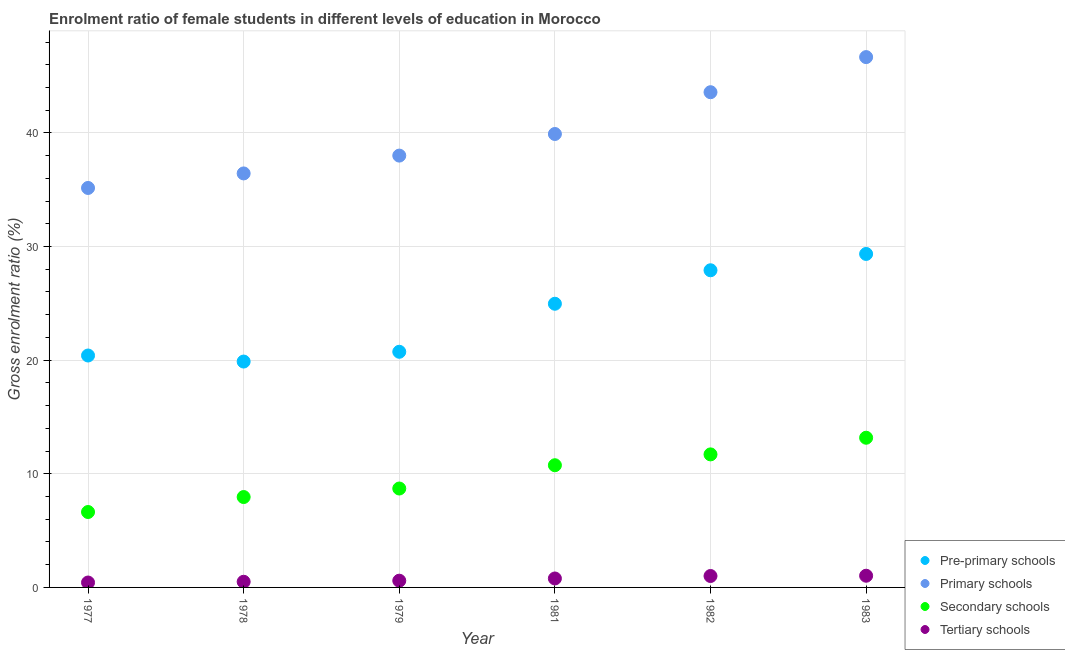What is the gross enrolment ratio(male) in pre-primary schools in 1978?
Ensure brevity in your answer.  19.88. Across all years, what is the maximum gross enrolment ratio(male) in primary schools?
Your answer should be compact. 46.67. Across all years, what is the minimum gross enrolment ratio(male) in primary schools?
Give a very brief answer. 35.16. In which year was the gross enrolment ratio(male) in primary schools maximum?
Give a very brief answer. 1983. In which year was the gross enrolment ratio(male) in pre-primary schools minimum?
Keep it short and to the point. 1978. What is the total gross enrolment ratio(male) in pre-primary schools in the graph?
Offer a terse response. 143.25. What is the difference between the gross enrolment ratio(male) in pre-primary schools in 1977 and that in 1983?
Your response must be concise. -8.94. What is the difference between the gross enrolment ratio(male) in pre-primary schools in 1981 and the gross enrolment ratio(male) in tertiary schools in 1983?
Keep it short and to the point. 23.94. What is the average gross enrolment ratio(male) in pre-primary schools per year?
Give a very brief answer. 23.87. In the year 1977, what is the difference between the gross enrolment ratio(male) in primary schools and gross enrolment ratio(male) in tertiary schools?
Your response must be concise. 34.72. What is the ratio of the gross enrolment ratio(male) in pre-primary schools in 1978 to that in 1982?
Ensure brevity in your answer.  0.71. Is the gross enrolment ratio(male) in tertiary schools in 1979 less than that in 1982?
Offer a very short reply. Yes. Is the difference between the gross enrolment ratio(male) in secondary schools in 1978 and 1979 greater than the difference between the gross enrolment ratio(male) in pre-primary schools in 1978 and 1979?
Provide a short and direct response. Yes. What is the difference between the highest and the second highest gross enrolment ratio(male) in secondary schools?
Your response must be concise. 1.47. What is the difference between the highest and the lowest gross enrolment ratio(male) in primary schools?
Offer a very short reply. 11.52. In how many years, is the gross enrolment ratio(male) in pre-primary schools greater than the average gross enrolment ratio(male) in pre-primary schools taken over all years?
Provide a succinct answer. 3. Is it the case that in every year, the sum of the gross enrolment ratio(male) in tertiary schools and gross enrolment ratio(male) in secondary schools is greater than the sum of gross enrolment ratio(male) in pre-primary schools and gross enrolment ratio(male) in primary schools?
Keep it short and to the point. No. Is it the case that in every year, the sum of the gross enrolment ratio(male) in pre-primary schools and gross enrolment ratio(male) in primary schools is greater than the gross enrolment ratio(male) in secondary schools?
Provide a succinct answer. Yes. Is the gross enrolment ratio(male) in secondary schools strictly greater than the gross enrolment ratio(male) in tertiary schools over the years?
Offer a very short reply. Yes. How many dotlines are there?
Offer a very short reply. 4. How many years are there in the graph?
Your answer should be compact. 6. What is the difference between two consecutive major ticks on the Y-axis?
Your answer should be compact. 10. Are the values on the major ticks of Y-axis written in scientific E-notation?
Offer a very short reply. No. Does the graph contain any zero values?
Keep it short and to the point. No. Does the graph contain grids?
Provide a short and direct response. Yes. Where does the legend appear in the graph?
Offer a very short reply. Bottom right. How many legend labels are there?
Ensure brevity in your answer.  4. How are the legend labels stacked?
Offer a very short reply. Vertical. What is the title of the graph?
Give a very brief answer. Enrolment ratio of female students in different levels of education in Morocco. What is the label or title of the X-axis?
Provide a succinct answer. Year. What is the label or title of the Y-axis?
Provide a succinct answer. Gross enrolment ratio (%). What is the Gross enrolment ratio (%) in Pre-primary schools in 1977?
Give a very brief answer. 20.41. What is the Gross enrolment ratio (%) in Primary schools in 1977?
Your answer should be very brief. 35.16. What is the Gross enrolment ratio (%) of Secondary schools in 1977?
Give a very brief answer. 6.64. What is the Gross enrolment ratio (%) in Tertiary schools in 1977?
Keep it short and to the point. 0.43. What is the Gross enrolment ratio (%) of Pre-primary schools in 1978?
Your answer should be compact. 19.88. What is the Gross enrolment ratio (%) in Primary schools in 1978?
Your answer should be compact. 36.43. What is the Gross enrolment ratio (%) in Secondary schools in 1978?
Keep it short and to the point. 7.95. What is the Gross enrolment ratio (%) of Tertiary schools in 1978?
Keep it short and to the point. 0.5. What is the Gross enrolment ratio (%) of Pre-primary schools in 1979?
Ensure brevity in your answer.  20.74. What is the Gross enrolment ratio (%) in Primary schools in 1979?
Offer a very short reply. 38. What is the Gross enrolment ratio (%) of Secondary schools in 1979?
Ensure brevity in your answer.  8.7. What is the Gross enrolment ratio (%) in Tertiary schools in 1979?
Your answer should be very brief. 0.59. What is the Gross enrolment ratio (%) in Pre-primary schools in 1981?
Provide a succinct answer. 24.96. What is the Gross enrolment ratio (%) of Primary schools in 1981?
Ensure brevity in your answer.  39.9. What is the Gross enrolment ratio (%) in Secondary schools in 1981?
Offer a terse response. 10.75. What is the Gross enrolment ratio (%) in Tertiary schools in 1981?
Offer a terse response. 0.79. What is the Gross enrolment ratio (%) in Pre-primary schools in 1982?
Give a very brief answer. 27.91. What is the Gross enrolment ratio (%) of Primary schools in 1982?
Keep it short and to the point. 43.58. What is the Gross enrolment ratio (%) in Secondary schools in 1982?
Keep it short and to the point. 11.71. What is the Gross enrolment ratio (%) in Tertiary schools in 1982?
Make the answer very short. 1.01. What is the Gross enrolment ratio (%) of Pre-primary schools in 1983?
Offer a terse response. 29.35. What is the Gross enrolment ratio (%) in Primary schools in 1983?
Offer a terse response. 46.67. What is the Gross enrolment ratio (%) in Secondary schools in 1983?
Provide a succinct answer. 13.17. What is the Gross enrolment ratio (%) in Tertiary schools in 1983?
Your answer should be compact. 1.03. Across all years, what is the maximum Gross enrolment ratio (%) of Pre-primary schools?
Offer a very short reply. 29.35. Across all years, what is the maximum Gross enrolment ratio (%) in Primary schools?
Your answer should be very brief. 46.67. Across all years, what is the maximum Gross enrolment ratio (%) in Secondary schools?
Ensure brevity in your answer.  13.17. Across all years, what is the maximum Gross enrolment ratio (%) in Tertiary schools?
Keep it short and to the point. 1.03. Across all years, what is the minimum Gross enrolment ratio (%) of Pre-primary schools?
Provide a short and direct response. 19.88. Across all years, what is the minimum Gross enrolment ratio (%) in Primary schools?
Make the answer very short. 35.16. Across all years, what is the minimum Gross enrolment ratio (%) in Secondary schools?
Your response must be concise. 6.64. Across all years, what is the minimum Gross enrolment ratio (%) of Tertiary schools?
Provide a short and direct response. 0.43. What is the total Gross enrolment ratio (%) in Pre-primary schools in the graph?
Provide a short and direct response. 143.25. What is the total Gross enrolment ratio (%) in Primary schools in the graph?
Ensure brevity in your answer.  239.75. What is the total Gross enrolment ratio (%) of Secondary schools in the graph?
Make the answer very short. 58.93. What is the total Gross enrolment ratio (%) in Tertiary schools in the graph?
Your answer should be very brief. 4.35. What is the difference between the Gross enrolment ratio (%) of Pre-primary schools in 1977 and that in 1978?
Ensure brevity in your answer.  0.53. What is the difference between the Gross enrolment ratio (%) of Primary schools in 1977 and that in 1978?
Your answer should be very brief. -1.28. What is the difference between the Gross enrolment ratio (%) in Secondary schools in 1977 and that in 1978?
Provide a short and direct response. -1.32. What is the difference between the Gross enrolment ratio (%) in Tertiary schools in 1977 and that in 1978?
Provide a short and direct response. -0.07. What is the difference between the Gross enrolment ratio (%) in Pre-primary schools in 1977 and that in 1979?
Offer a terse response. -0.33. What is the difference between the Gross enrolment ratio (%) of Primary schools in 1977 and that in 1979?
Your response must be concise. -2.85. What is the difference between the Gross enrolment ratio (%) in Secondary schools in 1977 and that in 1979?
Provide a short and direct response. -2.07. What is the difference between the Gross enrolment ratio (%) in Tertiary schools in 1977 and that in 1979?
Make the answer very short. -0.16. What is the difference between the Gross enrolment ratio (%) in Pre-primary schools in 1977 and that in 1981?
Your response must be concise. -4.55. What is the difference between the Gross enrolment ratio (%) of Primary schools in 1977 and that in 1981?
Your response must be concise. -4.75. What is the difference between the Gross enrolment ratio (%) in Secondary schools in 1977 and that in 1981?
Offer a terse response. -4.12. What is the difference between the Gross enrolment ratio (%) in Tertiary schools in 1977 and that in 1981?
Make the answer very short. -0.36. What is the difference between the Gross enrolment ratio (%) in Pre-primary schools in 1977 and that in 1982?
Offer a very short reply. -7.5. What is the difference between the Gross enrolment ratio (%) in Primary schools in 1977 and that in 1982?
Your response must be concise. -8.43. What is the difference between the Gross enrolment ratio (%) in Secondary schools in 1977 and that in 1982?
Make the answer very short. -5.07. What is the difference between the Gross enrolment ratio (%) of Tertiary schools in 1977 and that in 1982?
Your answer should be compact. -0.57. What is the difference between the Gross enrolment ratio (%) of Pre-primary schools in 1977 and that in 1983?
Your answer should be very brief. -8.94. What is the difference between the Gross enrolment ratio (%) of Primary schools in 1977 and that in 1983?
Offer a very short reply. -11.52. What is the difference between the Gross enrolment ratio (%) of Secondary schools in 1977 and that in 1983?
Give a very brief answer. -6.54. What is the difference between the Gross enrolment ratio (%) in Tertiary schools in 1977 and that in 1983?
Provide a succinct answer. -0.6. What is the difference between the Gross enrolment ratio (%) in Pre-primary schools in 1978 and that in 1979?
Offer a terse response. -0.86. What is the difference between the Gross enrolment ratio (%) of Primary schools in 1978 and that in 1979?
Give a very brief answer. -1.57. What is the difference between the Gross enrolment ratio (%) of Secondary schools in 1978 and that in 1979?
Make the answer very short. -0.75. What is the difference between the Gross enrolment ratio (%) of Tertiary schools in 1978 and that in 1979?
Keep it short and to the point. -0.09. What is the difference between the Gross enrolment ratio (%) in Pre-primary schools in 1978 and that in 1981?
Your answer should be very brief. -5.09. What is the difference between the Gross enrolment ratio (%) of Primary schools in 1978 and that in 1981?
Provide a succinct answer. -3.47. What is the difference between the Gross enrolment ratio (%) in Secondary schools in 1978 and that in 1981?
Make the answer very short. -2.8. What is the difference between the Gross enrolment ratio (%) in Tertiary schools in 1978 and that in 1981?
Give a very brief answer. -0.29. What is the difference between the Gross enrolment ratio (%) of Pre-primary schools in 1978 and that in 1982?
Offer a very short reply. -8.03. What is the difference between the Gross enrolment ratio (%) in Primary schools in 1978 and that in 1982?
Provide a succinct answer. -7.15. What is the difference between the Gross enrolment ratio (%) of Secondary schools in 1978 and that in 1982?
Provide a short and direct response. -3.75. What is the difference between the Gross enrolment ratio (%) in Tertiary schools in 1978 and that in 1982?
Your response must be concise. -0.51. What is the difference between the Gross enrolment ratio (%) of Pre-primary schools in 1978 and that in 1983?
Your response must be concise. -9.47. What is the difference between the Gross enrolment ratio (%) in Primary schools in 1978 and that in 1983?
Give a very brief answer. -10.24. What is the difference between the Gross enrolment ratio (%) of Secondary schools in 1978 and that in 1983?
Your answer should be compact. -5.22. What is the difference between the Gross enrolment ratio (%) in Tertiary schools in 1978 and that in 1983?
Provide a short and direct response. -0.53. What is the difference between the Gross enrolment ratio (%) in Pre-primary schools in 1979 and that in 1981?
Offer a very short reply. -4.23. What is the difference between the Gross enrolment ratio (%) in Primary schools in 1979 and that in 1981?
Give a very brief answer. -1.9. What is the difference between the Gross enrolment ratio (%) of Secondary schools in 1979 and that in 1981?
Offer a terse response. -2.05. What is the difference between the Gross enrolment ratio (%) of Tertiary schools in 1979 and that in 1981?
Keep it short and to the point. -0.2. What is the difference between the Gross enrolment ratio (%) in Pre-primary schools in 1979 and that in 1982?
Ensure brevity in your answer.  -7.17. What is the difference between the Gross enrolment ratio (%) of Primary schools in 1979 and that in 1982?
Provide a succinct answer. -5.58. What is the difference between the Gross enrolment ratio (%) in Secondary schools in 1979 and that in 1982?
Provide a succinct answer. -3. What is the difference between the Gross enrolment ratio (%) of Tertiary schools in 1979 and that in 1982?
Your response must be concise. -0.41. What is the difference between the Gross enrolment ratio (%) in Pre-primary schools in 1979 and that in 1983?
Ensure brevity in your answer.  -8.61. What is the difference between the Gross enrolment ratio (%) of Primary schools in 1979 and that in 1983?
Provide a short and direct response. -8.67. What is the difference between the Gross enrolment ratio (%) of Secondary schools in 1979 and that in 1983?
Ensure brevity in your answer.  -4.47. What is the difference between the Gross enrolment ratio (%) in Tertiary schools in 1979 and that in 1983?
Your answer should be compact. -0.44. What is the difference between the Gross enrolment ratio (%) in Pre-primary schools in 1981 and that in 1982?
Ensure brevity in your answer.  -2.95. What is the difference between the Gross enrolment ratio (%) of Primary schools in 1981 and that in 1982?
Provide a short and direct response. -3.68. What is the difference between the Gross enrolment ratio (%) in Secondary schools in 1981 and that in 1982?
Ensure brevity in your answer.  -0.95. What is the difference between the Gross enrolment ratio (%) of Tertiary schools in 1981 and that in 1982?
Your response must be concise. -0.22. What is the difference between the Gross enrolment ratio (%) of Pre-primary schools in 1981 and that in 1983?
Provide a short and direct response. -4.38. What is the difference between the Gross enrolment ratio (%) in Primary schools in 1981 and that in 1983?
Ensure brevity in your answer.  -6.77. What is the difference between the Gross enrolment ratio (%) in Secondary schools in 1981 and that in 1983?
Offer a very short reply. -2.42. What is the difference between the Gross enrolment ratio (%) in Tertiary schools in 1981 and that in 1983?
Ensure brevity in your answer.  -0.24. What is the difference between the Gross enrolment ratio (%) in Pre-primary schools in 1982 and that in 1983?
Provide a succinct answer. -1.44. What is the difference between the Gross enrolment ratio (%) in Primary schools in 1982 and that in 1983?
Offer a terse response. -3.09. What is the difference between the Gross enrolment ratio (%) in Secondary schools in 1982 and that in 1983?
Ensure brevity in your answer.  -1.47. What is the difference between the Gross enrolment ratio (%) in Tertiary schools in 1982 and that in 1983?
Offer a very short reply. -0.02. What is the difference between the Gross enrolment ratio (%) in Pre-primary schools in 1977 and the Gross enrolment ratio (%) in Primary schools in 1978?
Provide a succinct answer. -16.02. What is the difference between the Gross enrolment ratio (%) of Pre-primary schools in 1977 and the Gross enrolment ratio (%) of Secondary schools in 1978?
Your answer should be compact. 12.46. What is the difference between the Gross enrolment ratio (%) in Pre-primary schools in 1977 and the Gross enrolment ratio (%) in Tertiary schools in 1978?
Offer a very short reply. 19.91. What is the difference between the Gross enrolment ratio (%) of Primary schools in 1977 and the Gross enrolment ratio (%) of Secondary schools in 1978?
Keep it short and to the point. 27.2. What is the difference between the Gross enrolment ratio (%) in Primary schools in 1977 and the Gross enrolment ratio (%) in Tertiary schools in 1978?
Provide a short and direct response. 34.66. What is the difference between the Gross enrolment ratio (%) of Secondary schools in 1977 and the Gross enrolment ratio (%) of Tertiary schools in 1978?
Ensure brevity in your answer.  6.14. What is the difference between the Gross enrolment ratio (%) in Pre-primary schools in 1977 and the Gross enrolment ratio (%) in Primary schools in 1979?
Your answer should be compact. -17.59. What is the difference between the Gross enrolment ratio (%) of Pre-primary schools in 1977 and the Gross enrolment ratio (%) of Secondary schools in 1979?
Keep it short and to the point. 11.71. What is the difference between the Gross enrolment ratio (%) in Pre-primary schools in 1977 and the Gross enrolment ratio (%) in Tertiary schools in 1979?
Give a very brief answer. 19.82. What is the difference between the Gross enrolment ratio (%) in Primary schools in 1977 and the Gross enrolment ratio (%) in Secondary schools in 1979?
Provide a succinct answer. 26.45. What is the difference between the Gross enrolment ratio (%) in Primary schools in 1977 and the Gross enrolment ratio (%) in Tertiary schools in 1979?
Ensure brevity in your answer.  34.56. What is the difference between the Gross enrolment ratio (%) in Secondary schools in 1977 and the Gross enrolment ratio (%) in Tertiary schools in 1979?
Your answer should be very brief. 6.04. What is the difference between the Gross enrolment ratio (%) in Pre-primary schools in 1977 and the Gross enrolment ratio (%) in Primary schools in 1981?
Your response must be concise. -19.49. What is the difference between the Gross enrolment ratio (%) of Pre-primary schools in 1977 and the Gross enrolment ratio (%) of Secondary schools in 1981?
Your response must be concise. 9.66. What is the difference between the Gross enrolment ratio (%) in Pre-primary schools in 1977 and the Gross enrolment ratio (%) in Tertiary schools in 1981?
Ensure brevity in your answer.  19.62. What is the difference between the Gross enrolment ratio (%) of Primary schools in 1977 and the Gross enrolment ratio (%) of Secondary schools in 1981?
Your response must be concise. 24.4. What is the difference between the Gross enrolment ratio (%) in Primary schools in 1977 and the Gross enrolment ratio (%) in Tertiary schools in 1981?
Keep it short and to the point. 34.37. What is the difference between the Gross enrolment ratio (%) of Secondary schools in 1977 and the Gross enrolment ratio (%) of Tertiary schools in 1981?
Provide a succinct answer. 5.85. What is the difference between the Gross enrolment ratio (%) in Pre-primary schools in 1977 and the Gross enrolment ratio (%) in Primary schools in 1982?
Your response must be concise. -23.17. What is the difference between the Gross enrolment ratio (%) in Pre-primary schools in 1977 and the Gross enrolment ratio (%) in Secondary schools in 1982?
Provide a short and direct response. 8.7. What is the difference between the Gross enrolment ratio (%) in Pre-primary schools in 1977 and the Gross enrolment ratio (%) in Tertiary schools in 1982?
Keep it short and to the point. 19.4. What is the difference between the Gross enrolment ratio (%) in Primary schools in 1977 and the Gross enrolment ratio (%) in Secondary schools in 1982?
Your answer should be compact. 23.45. What is the difference between the Gross enrolment ratio (%) of Primary schools in 1977 and the Gross enrolment ratio (%) of Tertiary schools in 1982?
Your answer should be compact. 34.15. What is the difference between the Gross enrolment ratio (%) of Secondary schools in 1977 and the Gross enrolment ratio (%) of Tertiary schools in 1982?
Keep it short and to the point. 5.63. What is the difference between the Gross enrolment ratio (%) in Pre-primary schools in 1977 and the Gross enrolment ratio (%) in Primary schools in 1983?
Ensure brevity in your answer.  -26.26. What is the difference between the Gross enrolment ratio (%) of Pre-primary schools in 1977 and the Gross enrolment ratio (%) of Secondary schools in 1983?
Make the answer very short. 7.24. What is the difference between the Gross enrolment ratio (%) of Pre-primary schools in 1977 and the Gross enrolment ratio (%) of Tertiary schools in 1983?
Make the answer very short. 19.38. What is the difference between the Gross enrolment ratio (%) in Primary schools in 1977 and the Gross enrolment ratio (%) in Secondary schools in 1983?
Keep it short and to the point. 21.98. What is the difference between the Gross enrolment ratio (%) of Primary schools in 1977 and the Gross enrolment ratio (%) of Tertiary schools in 1983?
Make the answer very short. 34.13. What is the difference between the Gross enrolment ratio (%) of Secondary schools in 1977 and the Gross enrolment ratio (%) of Tertiary schools in 1983?
Your answer should be very brief. 5.61. What is the difference between the Gross enrolment ratio (%) of Pre-primary schools in 1978 and the Gross enrolment ratio (%) of Primary schools in 1979?
Your answer should be compact. -18.12. What is the difference between the Gross enrolment ratio (%) in Pre-primary schools in 1978 and the Gross enrolment ratio (%) in Secondary schools in 1979?
Make the answer very short. 11.17. What is the difference between the Gross enrolment ratio (%) of Pre-primary schools in 1978 and the Gross enrolment ratio (%) of Tertiary schools in 1979?
Provide a short and direct response. 19.29. What is the difference between the Gross enrolment ratio (%) of Primary schools in 1978 and the Gross enrolment ratio (%) of Secondary schools in 1979?
Your answer should be very brief. 27.73. What is the difference between the Gross enrolment ratio (%) of Primary schools in 1978 and the Gross enrolment ratio (%) of Tertiary schools in 1979?
Your response must be concise. 35.84. What is the difference between the Gross enrolment ratio (%) in Secondary schools in 1978 and the Gross enrolment ratio (%) in Tertiary schools in 1979?
Your answer should be compact. 7.36. What is the difference between the Gross enrolment ratio (%) in Pre-primary schools in 1978 and the Gross enrolment ratio (%) in Primary schools in 1981?
Provide a short and direct response. -20.03. What is the difference between the Gross enrolment ratio (%) of Pre-primary schools in 1978 and the Gross enrolment ratio (%) of Secondary schools in 1981?
Your answer should be very brief. 9.13. What is the difference between the Gross enrolment ratio (%) of Pre-primary schools in 1978 and the Gross enrolment ratio (%) of Tertiary schools in 1981?
Your answer should be very brief. 19.09. What is the difference between the Gross enrolment ratio (%) in Primary schools in 1978 and the Gross enrolment ratio (%) in Secondary schools in 1981?
Your answer should be compact. 25.68. What is the difference between the Gross enrolment ratio (%) of Primary schools in 1978 and the Gross enrolment ratio (%) of Tertiary schools in 1981?
Give a very brief answer. 35.65. What is the difference between the Gross enrolment ratio (%) of Secondary schools in 1978 and the Gross enrolment ratio (%) of Tertiary schools in 1981?
Ensure brevity in your answer.  7.17. What is the difference between the Gross enrolment ratio (%) in Pre-primary schools in 1978 and the Gross enrolment ratio (%) in Primary schools in 1982?
Offer a terse response. -23.7. What is the difference between the Gross enrolment ratio (%) of Pre-primary schools in 1978 and the Gross enrolment ratio (%) of Secondary schools in 1982?
Offer a terse response. 8.17. What is the difference between the Gross enrolment ratio (%) of Pre-primary schools in 1978 and the Gross enrolment ratio (%) of Tertiary schools in 1982?
Provide a short and direct response. 18.87. What is the difference between the Gross enrolment ratio (%) in Primary schools in 1978 and the Gross enrolment ratio (%) in Secondary schools in 1982?
Offer a very short reply. 24.73. What is the difference between the Gross enrolment ratio (%) of Primary schools in 1978 and the Gross enrolment ratio (%) of Tertiary schools in 1982?
Give a very brief answer. 35.43. What is the difference between the Gross enrolment ratio (%) in Secondary schools in 1978 and the Gross enrolment ratio (%) in Tertiary schools in 1982?
Your answer should be compact. 6.95. What is the difference between the Gross enrolment ratio (%) of Pre-primary schools in 1978 and the Gross enrolment ratio (%) of Primary schools in 1983?
Give a very brief answer. -26.79. What is the difference between the Gross enrolment ratio (%) in Pre-primary schools in 1978 and the Gross enrolment ratio (%) in Secondary schools in 1983?
Ensure brevity in your answer.  6.71. What is the difference between the Gross enrolment ratio (%) in Pre-primary schools in 1978 and the Gross enrolment ratio (%) in Tertiary schools in 1983?
Your answer should be compact. 18.85. What is the difference between the Gross enrolment ratio (%) of Primary schools in 1978 and the Gross enrolment ratio (%) of Secondary schools in 1983?
Keep it short and to the point. 23.26. What is the difference between the Gross enrolment ratio (%) of Primary schools in 1978 and the Gross enrolment ratio (%) of Tertiary schools in 1983?
Provide a short and direct response. 35.41. What is the difference between the Gross enrolment ratio (%) in Secondary schools in 1978 and the Gross enrolment ratio (%) in Tertiary schools in 1983?
Offer a terse response. 6.93. What is the difference between the Gross enrolment ratio (%) of Pre-primary schools in 1979 and the Gross enrolment ratio (%) of Primary schools in 1981?
Your answer should be compact. -19.17. What is the difference between the Gross enrolment ratio (%) in Pre-primary schools in 1979 and the Gross enrolment ratio (%) in Secondary schools in 1981?
Your answer should be compact. 9.98. What is the difference between the Gross enrolment ratio (%) in Pre-primary schools in 1979 and the Gross enrolment ratio (%) in Tertiary schools in 1981?
Provide a succinct answer. 19.95. What is the difference between the Gross enrolment ratio (%) in Primary schools in 1979 and the Gross enrolment ratio (%) in Secondary schools in 1981?
Make the answer very short. 27.25. What is the difference between the Gross enrolment ratio (%) in Primary schools in 1979 and the Gross enrolment ratio (%) in Tertiary schools in 1981?
Your answer should be compact. 37.21. What is the difference between the Gross enrolment ratio (%) of Secondary schools in 1979 and the Gross enrolment ratio (%) of Tertiary schools in 1981?
Offer a terse response. 7.92. What is the difference between the Gross enrolment ratio (%) in Pre-primary schools in 1979 and the Gross enrolment ratio (%) in Primary schools in 1982?
Keep it short and to the point. -22.84. What is the difference between the Gross enrolment ratio (%) of Pre-primary schools in 1979 and the Gross enrolment ratio (%) of Secondary schools in 1982?
Offer a very short reply. 9.03. What is the difference between the Gross enrolment ratio (%) in Pre-primary schools in 1979 and the Gross enrolment ratio (%) in Tertiary schools in 1982?
Give a very brief answer. 19.73. What is the difference between the Gross enrolment ratio (%) of Primary schools in 1979 and the Gross enrolment ratio (%) of Secondary schools in 1982?
Provide a succinct answer. 26.29. What is the difference between the Gross enrolment ratio (%) of Primary schools in 1979 and the Gross enrolment ratio (%) of Tertiary schools in 1982?
Give a very brief answer. 37. What is the difference between the Gross enrolment ratio (%) of Secondary schools in 1979 and the Gross enrolment ratio (%) of Tertiary schools in 1982?
Your response must be concise. 7.7. What is the difference between the Gross enrolment ratio (%) of Pre-primary schools in 1979 and the Gross enrolment ratio (%) of Primary schools in 1983?
Ensure brevity in your answer.  -25.93. What is the difference between the Gross enrolment ratio (%) of Pre-primary schools in 1979 and the Gross enrolment ratio (%) of Secondary schools in 1983?
Your answer should be compact. 7.56. What is the difference between the Gross enrolment ratio (%) of Pre-primary schools in 1979 and the Gross enrolment ratio (%) of Tertiary schools in 1983?
Provide a short and direct response. 19.71. What is the difference between the Gross enrolment ratio (%) in Primary schools in 1979 and the Gross enrolment ratio (%) in Secondary schools in 1983?
Your response must be concise. 24.83. What is the difference between the Gross enrolment ratio (%) of Primary schools in 1979 and the Gross enrolment ratio (%) of Tertiary schools in 1983?
Your response must be concise. 36.97. What is the difference between the Gross enrolment ratio (%) in Secondary schools in 1979 and the Gross enrolment ratio (%) in Tertiary schools in 1983?
Make the answer very short. 7.68. What is the difference between the Gross enrolment ratio (%) in Pre-primary schools in 1981 and the Gross enrolment ratio (%) in Primary schools in 1982?
Provide a short and direct response. -18.62. What is the difference between the Gross enrolment ratio (%) in Pre-primary schools in 1981 and the Gross enrolment ratio (%) in Secondary schools in 1982?
Your answer should be very brief. 13.26. What is the difference between the Gross enrolment ratio (%) of Pre-primary schools in 1981 and the Gross enrolment ratio (%) of Tertiary schools in 1982?
Provide a succinct answer. 23.96. What is the difference between the Gross enrolment ratio (%) of Primary schools in 1981 and the Gross enrolment ratio (%) of Secondary schools in 1982?
Your answer should be very brief. 28.2. What is the difference between the Gross enrolment ratio (%) in Primary schools in 1981 and the Gross enrolment ratio (%) in Tertiary schools in 1982?
Ensure brevity in your answer.  38.9. What is the difference between the Gross enrolment ratio (%) of Secondary schools in 1981 and the Gross enrolment ratio (%) of Tertiary schools in 1982?
Offer a terse response. 9.75. What is the difference between the Gross enrolment ratio (%) in Pre-primary schools in 1981 and the Gross enrolment ratio (%) in Primary schools in 1983?
Your response must be concise. -21.71. What is the difference between the Gross enrolment ratio (%) of Pre-primary schools in 1981 and the Gross enrolment ratio (%) of Secondary schools in 1983?
Your answer should be compact. 11.79. What is the difference between the Gross enrolment ratio (%) in Pre-primary schools in 1981 and the Gross enrolment ratio (%) in Tertiary schools in 1983?
Provide a short and direct response. 23.94. What is the difference between the Gross enrolment ratio (%) in Primary schools in 1981 and the Gross enrolment ratio (%) in Secondary schools in 1983?
Ensure brevity in your answer.  26.73. What is the difference between the Gross enrolment ratio (%) of Primary schools in 1981 and the Gross enrolment ratio (%) of Tertiary schools in 1983?
Give a very brief answer. 38.88. What is the difference between the Gross enrolment ratio (%) of Secondary schools in 1981 and the Gross enrolment ratio (%) of Tertiary schools in 1983?
Ensure brevity in your answer.  9.72. What is the difference between the Gross enrolment ratio (%) in Pre-primary schools in 1982 and the Gross enrolment ratio (%) in Primary schools in 1983?
Provide a succinct answer. -18.76. What is the difference between the Gross enrolment ratio (%) in Pre-primary schools in 1982 and the Gross enrolment ratio (%) in Secondary schools in 1983?
Give a very brief answer. 14.74. What is the difference between the Gross enrolment ratio (%) of Pre-primary schools in 1982 and the Gross enrolment ratio (%) of Tertiary schools in 1983?
Offer a very short reply. 26.88. What is the difference between the Gross enrolment ratio (%) of Primary schools in 1982 and the Gross enrolment ratio (%) of Secondary schools in 1983?
Provide a succinct answer. 30.41. What is the difference between the Gross enrolment ratio (%) in Primary schools in 1982 and the Gross enrolment ratio (%) in Tertiary schools in 1983?
Make the answer very short. 42.55. What is the difference between the Gross enrolment ratio (%) of Secondary schools in 1982 and the Gross enrolment ratio (%) of Tertiary schools in 1983?
Make the answer very short. 10.68. What is the average Gross enrolment ratio (%) in Pre-primary schools per year?
Provide a short and direct response. 23.88. What is the average Gross enrolment ratio (%) of Primary schools per year?
Provide a short and direct response. 39.96. What is the average Gross enrolment ratio (%) in Secondary schools per year?
Your response must be concise. 9.82. What is the average Gross enrolment ratio (%) of Tertiary schools per year?
Keep it short and to the point. 0.72. In the year 1977, what is the difference between the Gross enrolment ratio (%) of Pre-primary schools and Gross enrolment ratio (%) of Primary schools?
Offer a terse response. -14.75. In the year 1977, what is the difference between the Gross enrolment ratio (%) of Pre-primary schools and Gross enrolment ratio (%) of Secondary schools?
Your answer should be very brief. 13.77. In the year 1977, what is the difference between the Gross enrolment ratio (%) of Pre-primary schools and Gross enrolment ratio (%) of Tertiary schools?
Provide a succinct answer. 19.98. In the year 1977, what is the difference between the Gross enrolment ratio (%) of Primary schools and Gross enrolment ratio (%) of Secondary schools?
Ensure brevity in your answer.  28.52. In the year 1977, what is the difference between the Gross enrolment ratio (%) of Primary schools and Gross enrolment ratio (%) of Tertiary schools?
Give a very brief answer. 34.72. In the year 1977, what is the difference between the Gross enrolment ratio (%) of Secondary schools and Gross enrolment ratio (%) of Tertiary schools?
Keep it short and to the point. 6.2. In the year 1978, what is the difference between the Gross enrolment ratio (%) in Pre-primary schools and Gross enrolment ratio (%) in Primary schools?
Provide a succinct answer. -16.56. In the year 1978, what is the difference between the Gross enrolment ratio (%) in Pre-primary schools and Gross enrolment ratio (%) in Secondary schools?
Offer a terse response. 11.92. In the year 1978, what is the difference between the Gross enrolment ratio (%) of Pre-primary schools and Gross enrolment ratio (%) of Tertiary schools?
Ensure brevity in your answer.  19.38. In the year 1978, what is the difference between the Gross enrolment ratio (%) in Primary schools and Gross enrolment ratio (%) in Secondary schools?
Ensure brevity in your answer.  28.48. In the year 1978, what is the difference between the Gross enrolment ratio (%) of Primary schools and Gross enrolment ratio (%) of Tertiary schools?
Make the answer very short. 35.94. In the year 1978, what is the difference between the Gross enrolment ratio (%) in Secondary schools and Gross enrolment ratio (%) in Tertiary schools?
Provide a short and direct response. 7.46. In the year 1979, what is the difference between the Gross enrolment ratio (%) in Pre-primary schools and Gross enrolment ratio (%) in Primary schools?
Offer a terse response. -17.26. In the year 1979, what is the difference between the Gross enrolment ratio (%) in Pre-primary schools and Gross enrolment ratio (%) in Secondary schools?
Offer a terse response. 12.03. In the year 1979, what is the difference between the Gross enrolment ratio (%) in Pre-primary schools and Gross enrolment ratio (%) in Tertiary schools?
Your response must be concise. 20.15. In the year 1979, what is the difference between the Gross enrolment ratio (%) of Primary schools and Gross enrolment ratio (%) of Secondary schools?
Provide a short and direct response. 29.3. In the year 1979, what is the difference between the Gross enrolment ratio (%) of Primary schools and Gross enrolment ratio (%) of Tertiary schools?
Offer a terse response. 37.41. In the year 1979, what is the difference between the Gross enrolment ratio (%) in Secondary schools and Gross enrolment ratio (%) in Tertiary schools?
Give a very brief answer. 8.11. In the year 1981, what is the difference between the Gross enrolment ratio (%) of Pre-primary schools and Gross enrolment ratio (%) of Primary schools?
Offer a very short reply. -14.94. In the year 1981, what is the difference between the Gross enrolment ratio (%) of Pre-primary schools and Gross enrolment ratio (%) of Secondary schools?
Keep it short and to the point. 14.21. In the year 1981, what is the difference between the Gross enrolment ratio (%) of Pre-primary schools and Gross enrolment ratio (%) of Tertiary schools?
Your response must be concise. 24.18. In the year 1981, what is the difference between the Gross enrolment ratio (%) of Primary schools and Gross enrolment ratio (%) of Secondary schools?
Offer a terse response. 29.15. In the year 1981, what is the difference between the Gross enrolment ratio (%) in Primary schools and Gross enrolment ratio (%) in Tertiary schools?
Ensure brevity in your answer.  39.12. In the year 1981, what is the difference between the Gross enrolment ratio (%) of Secondary schools and Gross enrolment ratio (%) of Tertiary schools?
Ensure brevity in your answer.  9.97. In the year 1982, what is the difference between the Gross enrolment ratio (%) in Pre-primary schools and Gross enrolment ratio (%) in Primary schools?
Make the answer very short. -15.67. In the year 1982, what is the difference between the Gross enrolment ratio (%) in Pre-primary schools and Gross enrolment ratio (%) in Secondary schools?
Offer a terse response. 16.2. In the year 1982, what is the difference between the Gross enrolment ratio (%) of Pre-primary schools and Gross enrolment ratio (%) of Tertiary schools?
Ensure brevity in your answer.  26.91. In the year 1982, what is the difference between the Gross enrolment ratio (%) of Primary schools and Gross enrolment ratio (%) of Secondary schools?
Your answer should be compact. 31.87. In the year 1982, what is the difference between the Gross enrolment ratio (%) in Primary schools and Gross enrolment ratio (%) in Tertiary schools?
Keep it short and to the point. 42.58. In the year 1982, what is the difference between the Gross enrolment ratio (%) of Secondary schools and Gross enrolment ratio (%) of Tertiary schools?
Offer a very short reply. 10.7. In the year 1983, what is the difference between the Gross enrolment ratio (%) in Pre-primary schools and Gross enrolment ratio (%) in Primary schools?
Make the answer very short. -17.32. In the year 1983, what is the difference between the Gross enrolment ratio (%) of Pre-primary schools and Gross enrolment ratio (%) of Secondary schools?
Ensure brevity in your answer.  16.17. In the year 1983, what is the difference between the Gross enrolment ratio (%) in Pre-primary schools and Gross enrolment ratio (%) in Tertiary schools?
Your answer should be compact. 28.32. In the year 1983, what is the difference between the Gross enrolment ratio (%) of Primary schools and Gross enrolment ratio (%) of Secondary schools?
Give a very brief answer. 33.5. In the year 1983, what is the difference between the Gross enrolment ratio (%) of Primary schools and Gross enrolment ratio (%) of Tertiary schools?
Your response must be concise. 45.64. In the year 1983, what is the difference between the Gross enrolment ratio (%) of Secondary schools and Gross enrolment ratio (%) of Tertiary schools?
Offer a very short reply. 12.14. What is the ratio of the Gross enrolment ratio (%) of Pre-primary schools in 1977 to that in 1978?
Provide a succinct answer. 1.03. What is the ratio of the Gross enrolment ratio (%) of Primary schools in 1977 to that in 1978?
Your answer should be very brief. 0.96. What is the ratio of the Gross enrolment ratio (%) of Secondary schools in 1977 to that in 1978?
Offer a terse response. 0.83. What is the ratio of the Gross enrolment ratio (%) in Tertiary schools in 1977 to that in 1978?
Offer a terse response. 0.87. What is the ratio of the Gross enrolment ratio (%) in Pre-primary schools in 1977 to that in 1979?
Keep it short and to the point. 0.98. What is the ratio of the Gross enrolment ratio (%) of Primary schools in 1977 to that in 1979?
Your response must be concise. 0.93. What is the ratio of the Gross enrolment ratio (%) in Secondary schools in 1977 to that in 1979?
Keep it short and to the point. 0.76. What is the ratio of the Gross enrolment ratio (%) of Tertiary schools in 1977 to that in 1979?
Provide a succinct answer. 0.73. What is the ratio of the Gross enrolment ratio (%) of Pre-primary schools in 1977 to that in 1981?
Keep it short and to the point. 0.82. What is the ratio of the Gross enrolment ratio (%) in Primary schools in 1977 to that in 1981?
Keep it short and to the point. 0.88. What is the ratio of the Gross enrolment ratio (%) in Secondary schools in 1977 to that in 1981?
Keep it short and to the point. 0.62. What is the ratio of the Gross enrolment ratio (%) of Tertiary schools in 1977 to that in 1981?
Offer a terse response. 0.55. What is the ratio of the Gross enrolment ratio (%) in Pre-primary schools in 1977 to that in 1982?
Your answer should be compact. 0.73. What is the ratio of the Gross enrolment ratio (%) in Primary schools in 1977 to that in 1982?
Your answer should be very brief. 0.81. What is the ratio of the Gross enrolment ratio (%) of Secondary schools in 1977 to that in 1982?
Your response must be concise. 0.57. What is the ratio of the Gross enrolment ratio (%) in Tertiary schools in 1977 to that in 1982?
Your response must be concise. 0.43. What is the ratio of the Gross enrolment ratio (%) of Pre-primary schools in 1977 to that in 1983?
Provide a succinct answer. 0.7. What is the ratio of the Gross enrolment ratio (%) of Primary schools in 1977 to that in 1983?
Make the answer very short. 0.75. What is the ratio of the Gross enrolment ratio (%) of Secondary schools in 1977 to that in 1983?
Your answer should be very brief. 0.5. What is the ratio of the Gross enrolment ratio (%) of Tertiary schools in 1977 to that in 1983?
Your answer should be compact. 0.42. What is the ratio of the Gross enrolment ratio (%) in Pre-primary schools in 1978 to that in 1979?
Ensure brevity in your answer.  0.96. What is the ratio of the Gross enrolment ratio (%) in Primary schools in 1978 to that in 1979?
Give a very brief answer. 0.96. What is the ratio of the Gross enrolment ratio (%) in Secondary schools in 1978 to that in 1979?
Keep it short and to the point. 0.91. What is the ratio of the Gross enrolment ratio (%) in Tertiary schools in 1978 to that in 1979?
Keep it short and to the point. 0.84. What is the ratio of the Gross enrolment ratio (%) in Pre-primary schools in 1978 to that in 1981?
Provide a short and direct response. 0.8. What is the ratio of the Gross enrolment ratio (%) of Primary schools in 1978 to that in 1981?
Your answer should be very brief. 0.91. What is the ratio of the Gross enrolment ratio (%) in Secondary schools in 1978 to that in 1981?
Your answer should be compact. 0.74. What is the ratio of the Gross enrolment ratio (%) of Tertiary schools in 1978 to that in 1981?
Offer a terse response. 0.63. What is the ratio of the Gross enrolment ratio (%) in Pre-primary schools in 1978 to that in 1982?
Offer a terse response. 0.71. What is the ratio of the Gross enrolment ratio (%) in Primary schools in 1978 to that in 1982?
Make the answer very short. 0.84. What is the ratio of the Gross enrolment ratio (%) in Secondary schools in 1978 to that in 1982?
Offer a terse response. 0.68. What is the ratio of the Gross enrolment ratio (%) in Tertiary schools in 1978 to that in 1982?
Offer a terse response. 0.5. What is the ratio of the Gross enrolment ratio (%) of Pre-primary schools in 1978 to that in 1983?
Your answer should be very brief. 0.68. What is the ratio of the Gross enrolment ratio (%) in Primary schools in 1978 to that in 1983?
Your response must be concise. 0.78. What is the ratio of the Gross enrolment ratio (%) of Secondary schools in 1978 to that in 1983?
Your answer should be very brief. 0.6. What is the ratio of the Gross enrolment ratio (%) in Tertiary schools in 1978 to that in 1983?
Your answer should be very brief. 0.48. What is the ratio of the Gross enrolment ratio (%) in Pre-primary schools in 1979 to that in 1981?
Provide a succinct answer. 0.83. What is the ratio of the Gross enrolment ratio (%) of Primary schools in 1979 to that in 1981?
Your answer should be compact. 0.95. What is the ratio of the Gross enrolment ratio (%) in Secondary schools in 1979 to that in 1981?
Ensure brevity in your answer.  0.81. What is the ratio of the Gross enrolment ratio (%) in Tertiary schools in 1979 to that in 1981?
Ensure brevity in your answer.  0.75. What is the ratio of the Gross enrolment ratio (%) in Pre-primary schools in 1979 to that in 1982?
Make the answer very short. 0.74. What is the ratio of the Gross enrolment ratio (%) of Primary schools in 1979 to that in 1982?
Provide a short and direct response. 0.87. What is the ratio of the Gross enrolment ratio (%) of Secondary schools in 1979 to that in 1982?
Offer a very short reply. 0.74. What is the ratio of the Gross enrolment ratio (%) of Tertiary schools in 1979 to that in 1982?
Offer a terse response. 0.59. What is the ratio of the Gross enrolment ratio (%) in Pre-primary schools in 1979 to that in 1983?
Provide a succinct answer. 0.71. What is the ratio of the Gross enrolment ratio (%) of Primary schools in 1979 to that in 1983?
Keep it short and to the point. 0.81. What is the ratio of the Gross enrolment ratio (%) of Secondary schools in 1979 to that in 1983?
Your answer should be compact. 0.66. What is the ratio of the Gross enrolment ratio (%) in Tertiary schools in 1979 to that in 1983?
Your response must be concise. 0.58. What is the ratio of the Gross enrolment ratio (%) in Pre-primary schools in 1981 to that in 1982?
Your response must be concise. 0.89. What is the ratio of the Gross enrolment ratio (%) of Primary schools in 1981 to that in 1982?
Provide a short and direct response. 0.92. What is the ratio of the Gross enrolment ratio (%) of Secondary schools in 1981 to that in 1982?
Provide a succinct answer. 0.92. What is the ratio of the Gross enrolment ratio (%) of Tertiary schools in 1981 to that in 1982?
Your response must be concise. 0.78. What is the ratio of the Gross enrolment ratio (%) in Pre-primary schools in 1981 to that in 1983?
Provide a short and direct response. 0.85. What is the ratio of the Gross enrolment ratio (%) in Primary schools in 1981 to that in 1983?
Offer a terse response. 0.85. What is the ratio of the Gross enrolment ratio (%) of Secondary schools in 1981 to that in 1983?
Give a very brief answer. 0.82. What is the ratio of the Gross enrolment ratio (%) of Tertiary schools in 1981 to that in 1983?
Make the answer very short. 0.77. What is the ratio of the Gross enrolment ratio (%) of Pre-primary schools in 1982 to that in 1983?
Make the answer very short. 0.95. What is the ratio of the Gross enrolment ratio (%) of Primary schools in 1982 to that in 1983?
Offer a very short reply. 0.93. What is the ratio of the Gross enrolment ratio (%) in Secondary schools in 1982 to that in 1983?
Ensure brevity in your answer.  0.89. What is the ratio of the Gross enrolment ratio (%) of Tertiary schools in 1982 to that in 1983?
Offer a terse response. 0.98. What is the difference between the highest and the second highest Gross enrolment ratio (%) of Pre-primary schools?
Provide a short and direct response. 1.44. What is the difference between the highest and the second highest Gross enrolment ratio (%) in Primary schools?
Keep it short and to the point. 3.09. What is the difference between the highest and the second highest Gross enrolment ratio (%) of Secondary schools?
Provide a short and direct response. 1.47. What is the difference between the highest and the second highest Gross enrolment ratio (%) in Tertiary schools?
Keep it short and to the point. 0.02. What is the difference between the highest and the lowest Gross enrolment ratio (%) in Pre-primary schools?
Your answer should be very brief. 9.47. What is the difference between the highest and the lowest Gross enrolment ratio (%) of Primary schools?
Provide a succinct answer. 11.52. What is the difference between the highest and the lowest Gross enrolment ratio (%) in Secondary schools?
Offer a terse response. 6.54. What is the difference between the highest and the lowest Gross enrolment ratio (%) of Tertiary schools?
Offer a terse response. 0.6. 